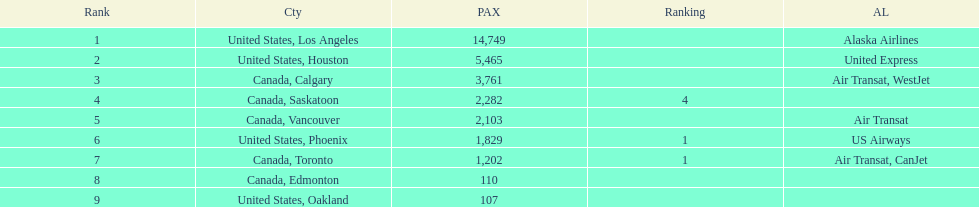How many more passengers flew to los angeles than to saskatoon from manzanillo airport in 2013? 12,467. 